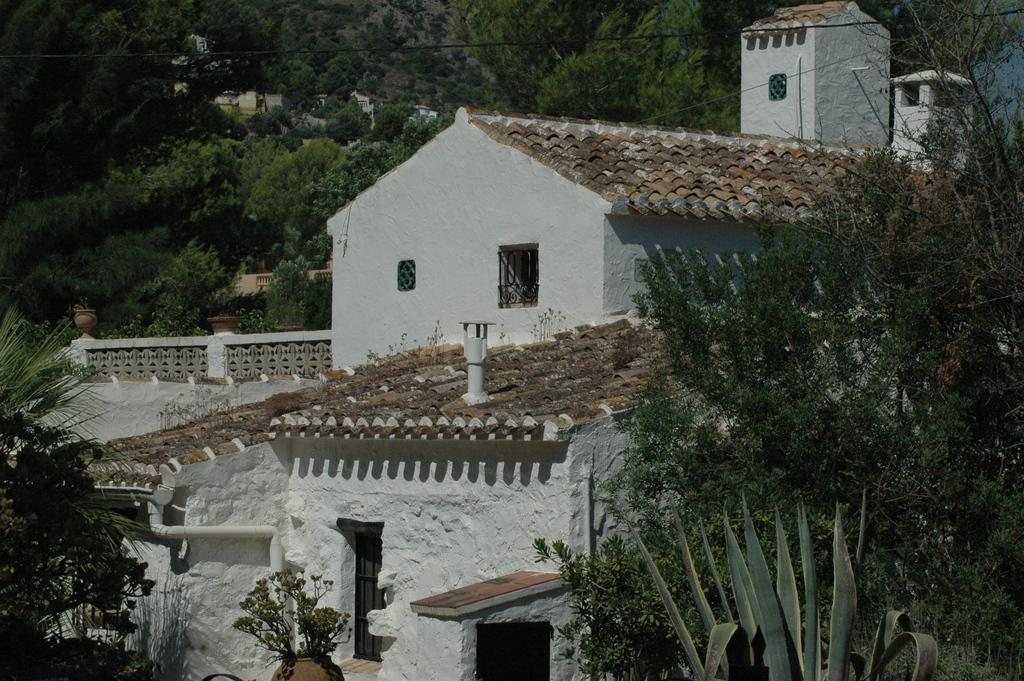What is the main subject in the center of the image? There is a building in the center of the image. What can be seen at the bottom of the image? There are plants at the bottom of the image. What is visible in the background of the image? There are trees and wires in the background of the image. How many horses can be seen in the image? There are no horses present in the image. 